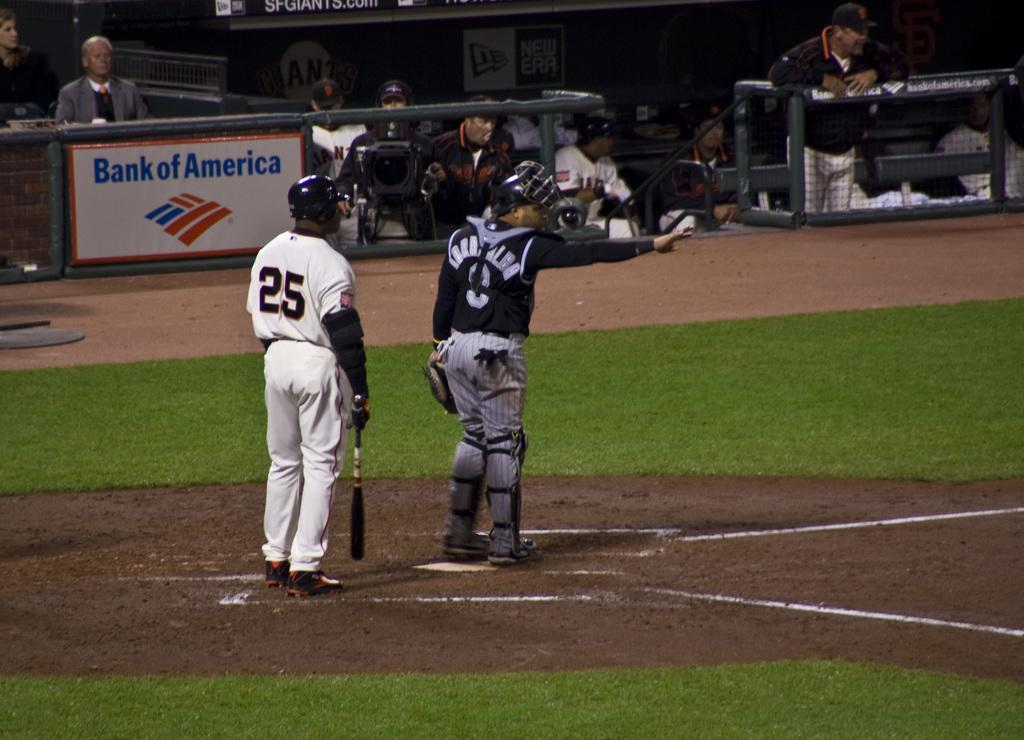<image>
Share a concise interpretation of the image provided. a player with 25 on their jersey next to a catcher 